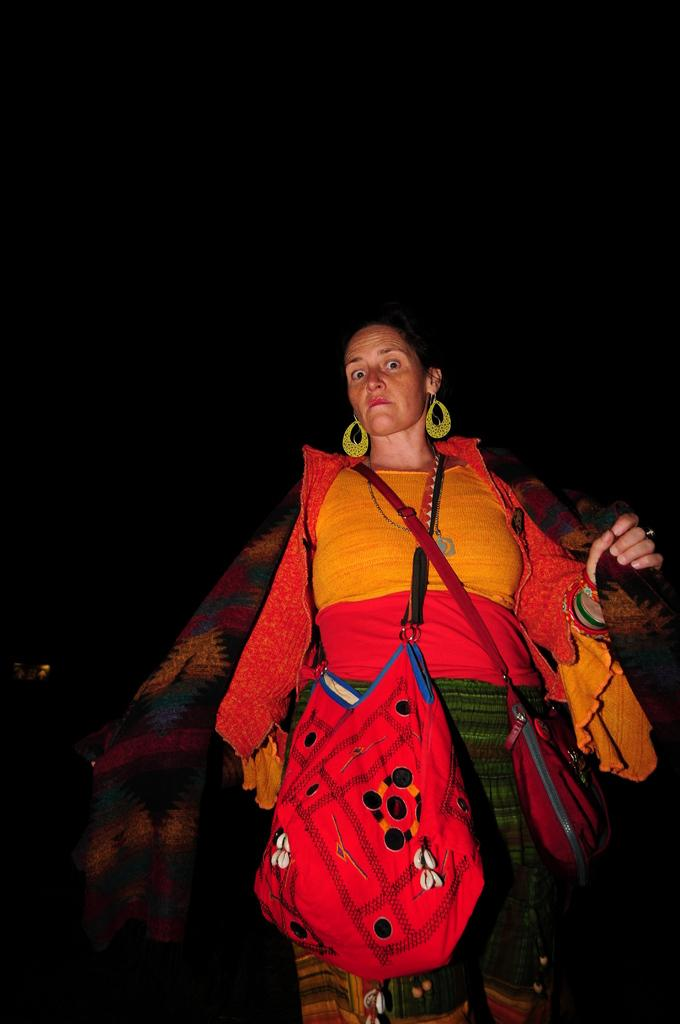Who is present in the image? There is a woman in the image. What is the woman wearing? The woman is wearing a jacket. What type of bag does the woman have? The woman has a side bag. Where is the side bag located in the image? The side bag is visible at the bottom of the image. What can be said about the background of the image? The background of the image is dark. What type of egg is being cooked in the image? There is no egg present in the image; it features a woman wearing a jacket and carrying a side bag with a dark background. 